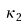<formula> <loc_0><loc_0><loc_500><loc_500>\, \kappa _ { 2 }</formula> 